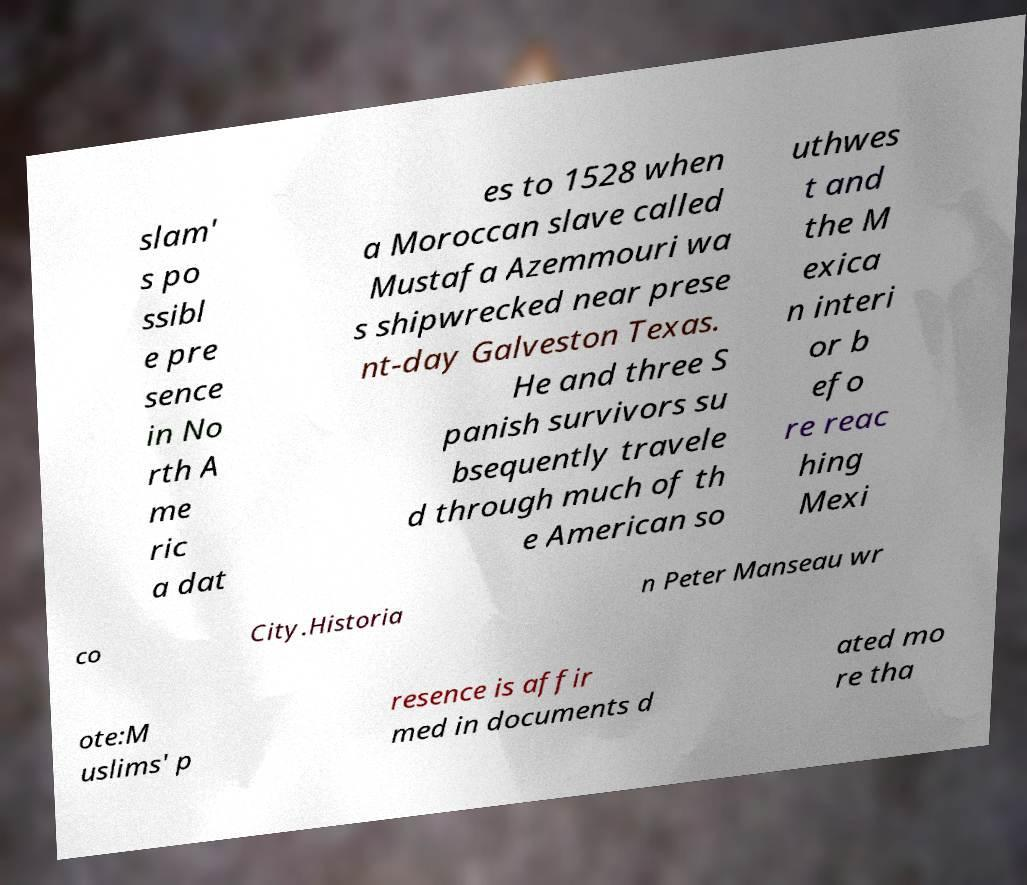Please read and relay the text visible in this image. What does it say? slam' s po ssibl e pre sence in No rth A me ric a dat es to 1528 when a Moroccan slave called Mustafa Azemmouri wa s shipwrecked near prese nt-day Galveston Texas. He and three S panish survivors su bsequently travele d through much of th e American so uthwes t and the M exica n interi or b efo re reac hing Mexi co City.Historia n Peter Manseau wr ote:M uslims' p resence is affir med in documents d ated mo re tha 